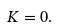<formula> <loc_0><loc_0><loc_500><loc_500>K = 0 .</formula> 